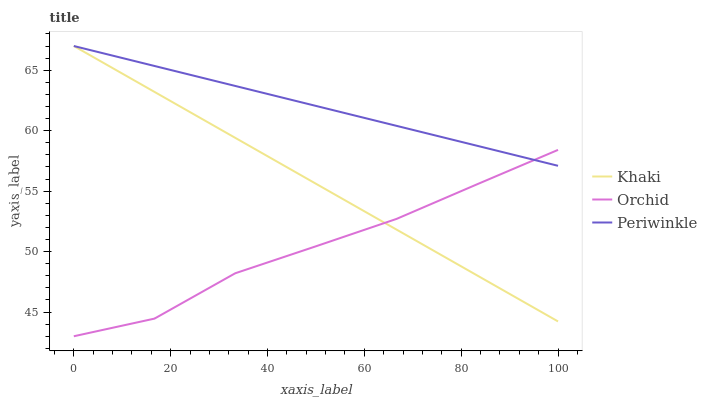Does Periwinkle have the minimum area under the curve?
Answer yes or no. No. Does Orchid have the maximum area under the curve?
Answer yes or no. No. Is Orchid the smoothest?
Answer yes or no. No. Is Periwinkle the roughest?
Answer yes or no. No. Does Periwinkle have the lowest value?
Answer yes or no. No. Does Orchid have the highest value?
Answer yes or no. No. 